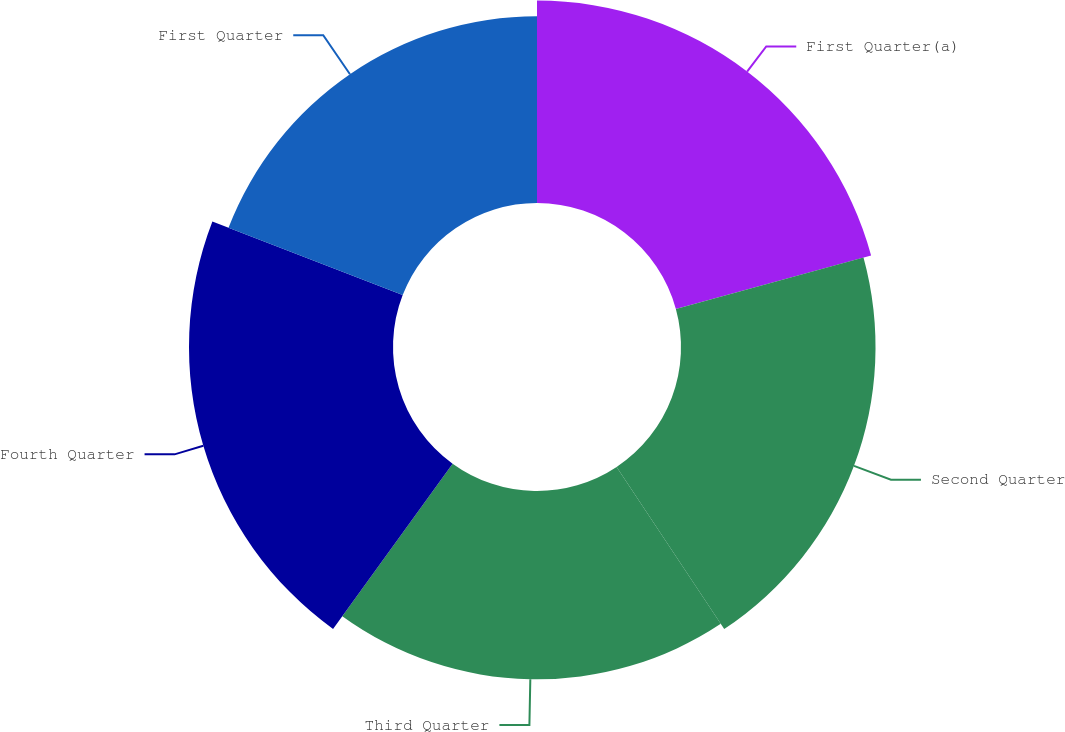Convert chart. <chart><loc_0><loc_0><loc_500><loc_500><pie_chart><fcel>First Quarter(a)<fcel>Second Quarter<fcel>Third Quarter<fcel>Fourth Quarter<fcel>First Quarter<nl><fcel>20.74%<fcel>19.93%<fcel>19.29%<fcel>20.9%<fcel>19.13%<nl></chart> 